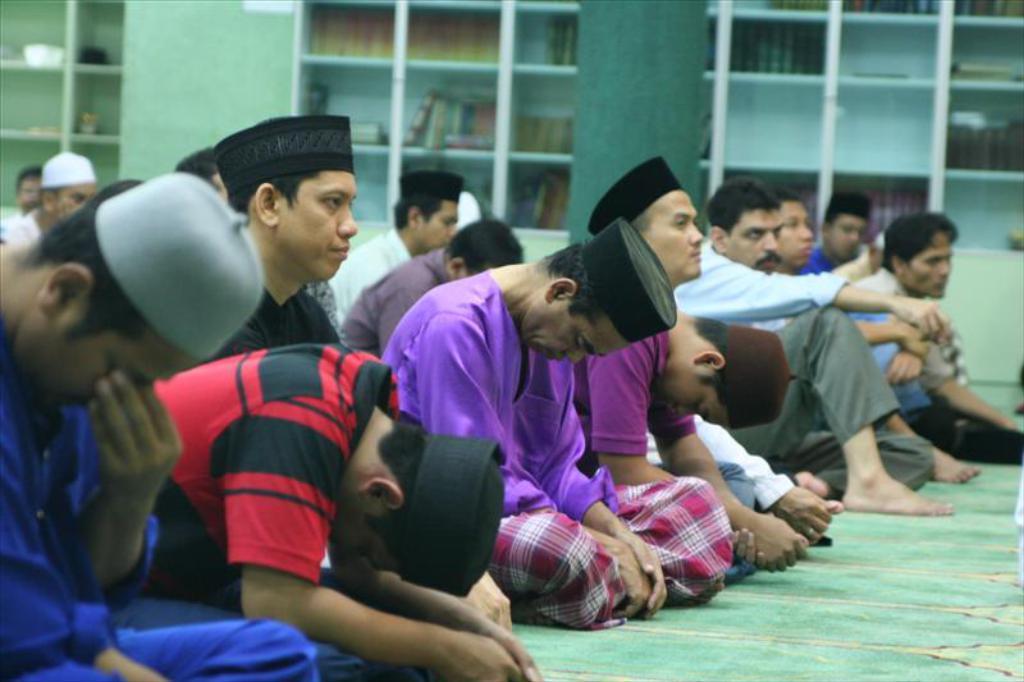Please provide a concise description of this image. In this picture we can see some people wore caps and a group of people sitting on the floor. In the background we can see books on shelves and the walls. 